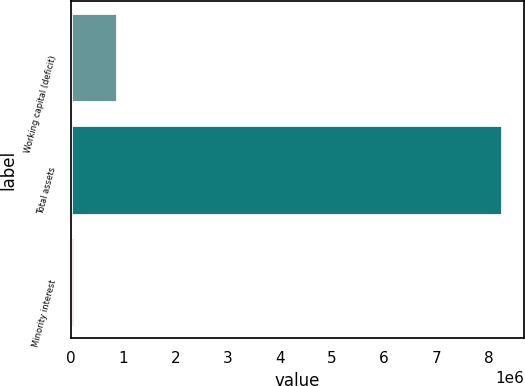<chart> <loc_0><loc_0><loc_500><loc_500><bar_chart><fcel>Working capital (deficit)<fcel>Total assets<fcel>Minority interest<nl><fcel>882012<fcel>8.26432e+06<fcel>61756<nl></chart> 